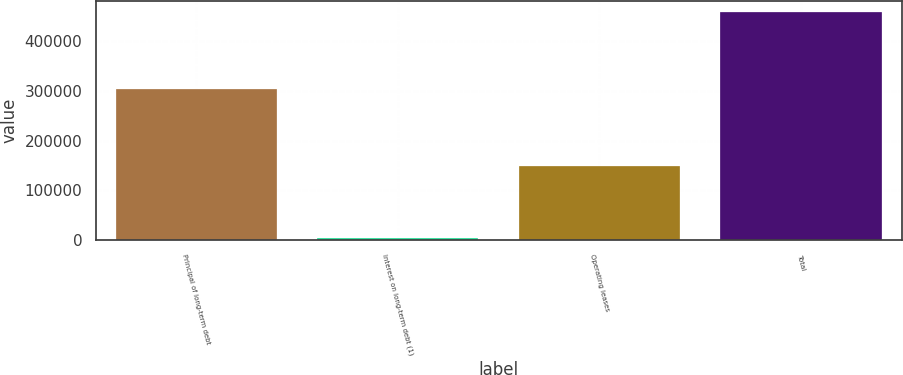<chart> <loc_0><loc_0><loc_500><loc_500><bar_chart><fcel>Principal of long-term debt<fcel>Interest on long-term debt (1)<fcel>Operating leases<fcel>Total<nl><fcel>304518<fcel>4311<fcel>148785<fcel>457614<nl></chart> 